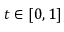Convert formula to latex. <formula><loc_0><loc_0><loc_500><loc_500>t \in [ 0 , 1 ]</formula> 